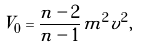Convert formula to latex. <formula><loc_0><loc_0><loc_500><loc_500>V _ { 0 } = \frac { n - 2 } { n - 1 } m ^ { 2 } v ^ { 2 } ,</formula> 